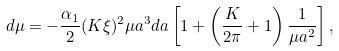Convert formula to latex. <formula><loc_0><loc_0><loc_500><loc_500>d \mu = - \frac { \alpha _ { 1 } } { 2 } ( K \xi ) ^ { 2 } \mu a ^ { 3 } d a \left [ 1 + \left ( \frac { K } { 2 \pi } + 1 \right ) \frac { 1 } { \mu a ^ { 2 } } \right ] ,</formula> 